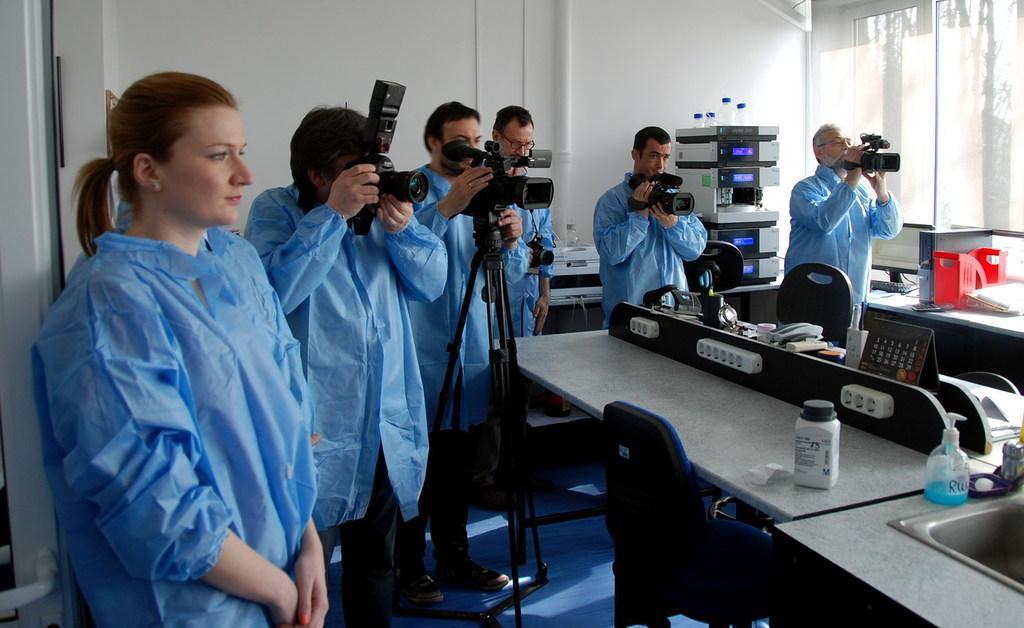In one or two sentences, can you explain what this image depicts? These people are holding cameras. On these tables there are bottles, monitor, calendar and things. Beside this table there are chairs. Floor with carpet. Backside of these people there is a table, above the table there is a machine and things. This is windows. Background there is a white wall. Backside of this woman there is a door.  